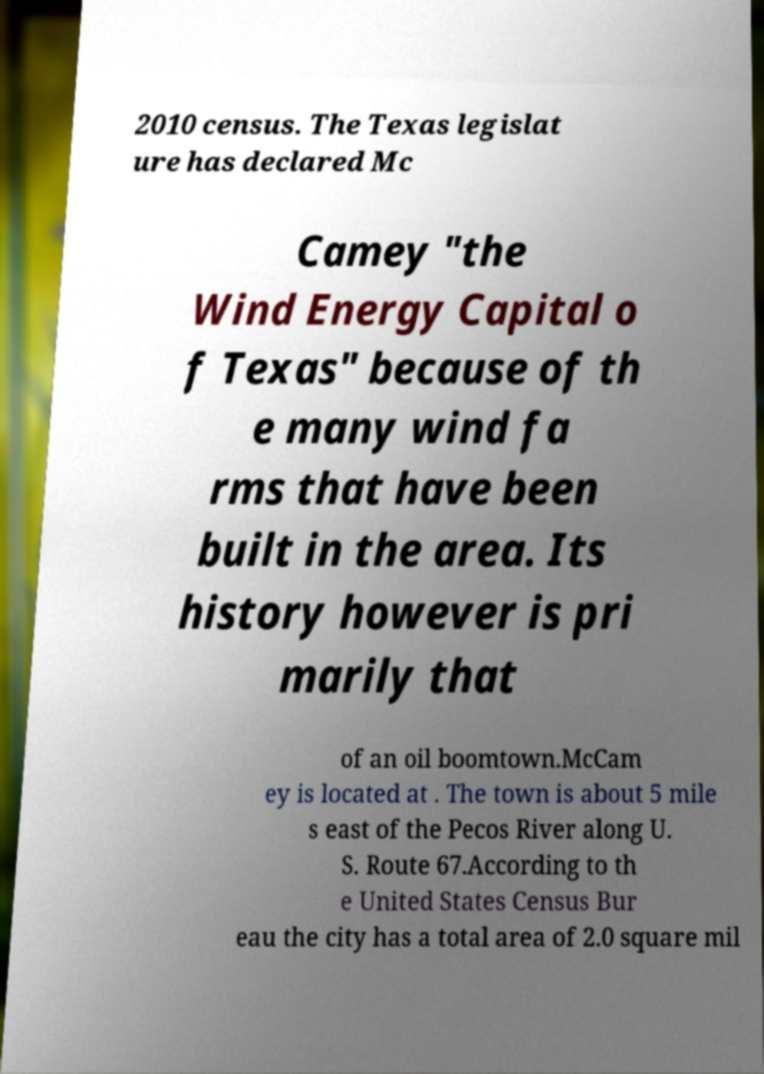For documentation purposes, I need the text within this image transcribed. Could you provide that? 2010 census. The Texas legislat ure has declared Mc Camey "the Wind Energy Capital o f Texas" because of th e many wind fa rms that have been built in the area. Its history however is pri marily that of an oil boomtown.McCam ey is located at . The town is about 5 mile s east of the Pecos River along U. S. Route 67.According to th e United States Census Bur eau the city has a total area of 2.0 square mil 